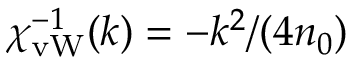Convert formula to latex. <formula><loc_0><loc_0><loc_500><loc_500>\chi _ { v W } ^ { - 1 } ( k ) = - k ^ { 2 } / ( 4 n _ { 0 } )</formula> 